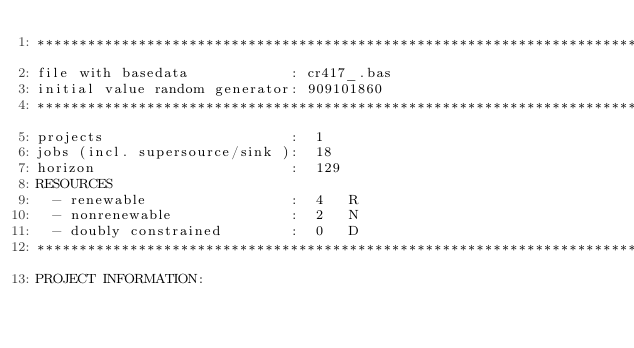<code> <loc_0><loc_0><loc_500><loc_500><_ObjectiveC_>************************************************************************
file with basedata            : cr417_.bas
initial value random generator: 909101860
************************************************************************
projects                      :  1
jobs (incl. supersource/sink ):  18
horizon                       :  129
RESOURCES
  - renewable                 :  4   R
  - nonrenewable              :  2   N
  - doubly constrained        :  0   D
************************************************************************
PROJECT INFORMATION:</code> 